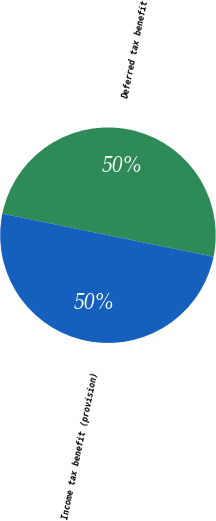<chart> <loc_0><loc_0><loc_500><loc_500><pie_chart><fcel>Deferred tax benefit<fcel>Income tax benefit (provision)<nl><fcel>49.99%<fcel>50.01%<nl></chart> 